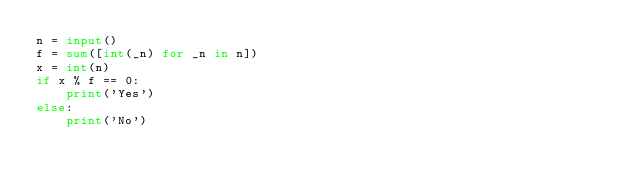Convert code to text. <code><loc_0><loc_0><loc_500><loc_500><_Python_>n = input()
f = sum([int(_n) for _n in n])
x = int(n)
if x % f == 0:
    print('Yes')
else:
    print('No')
</code> 